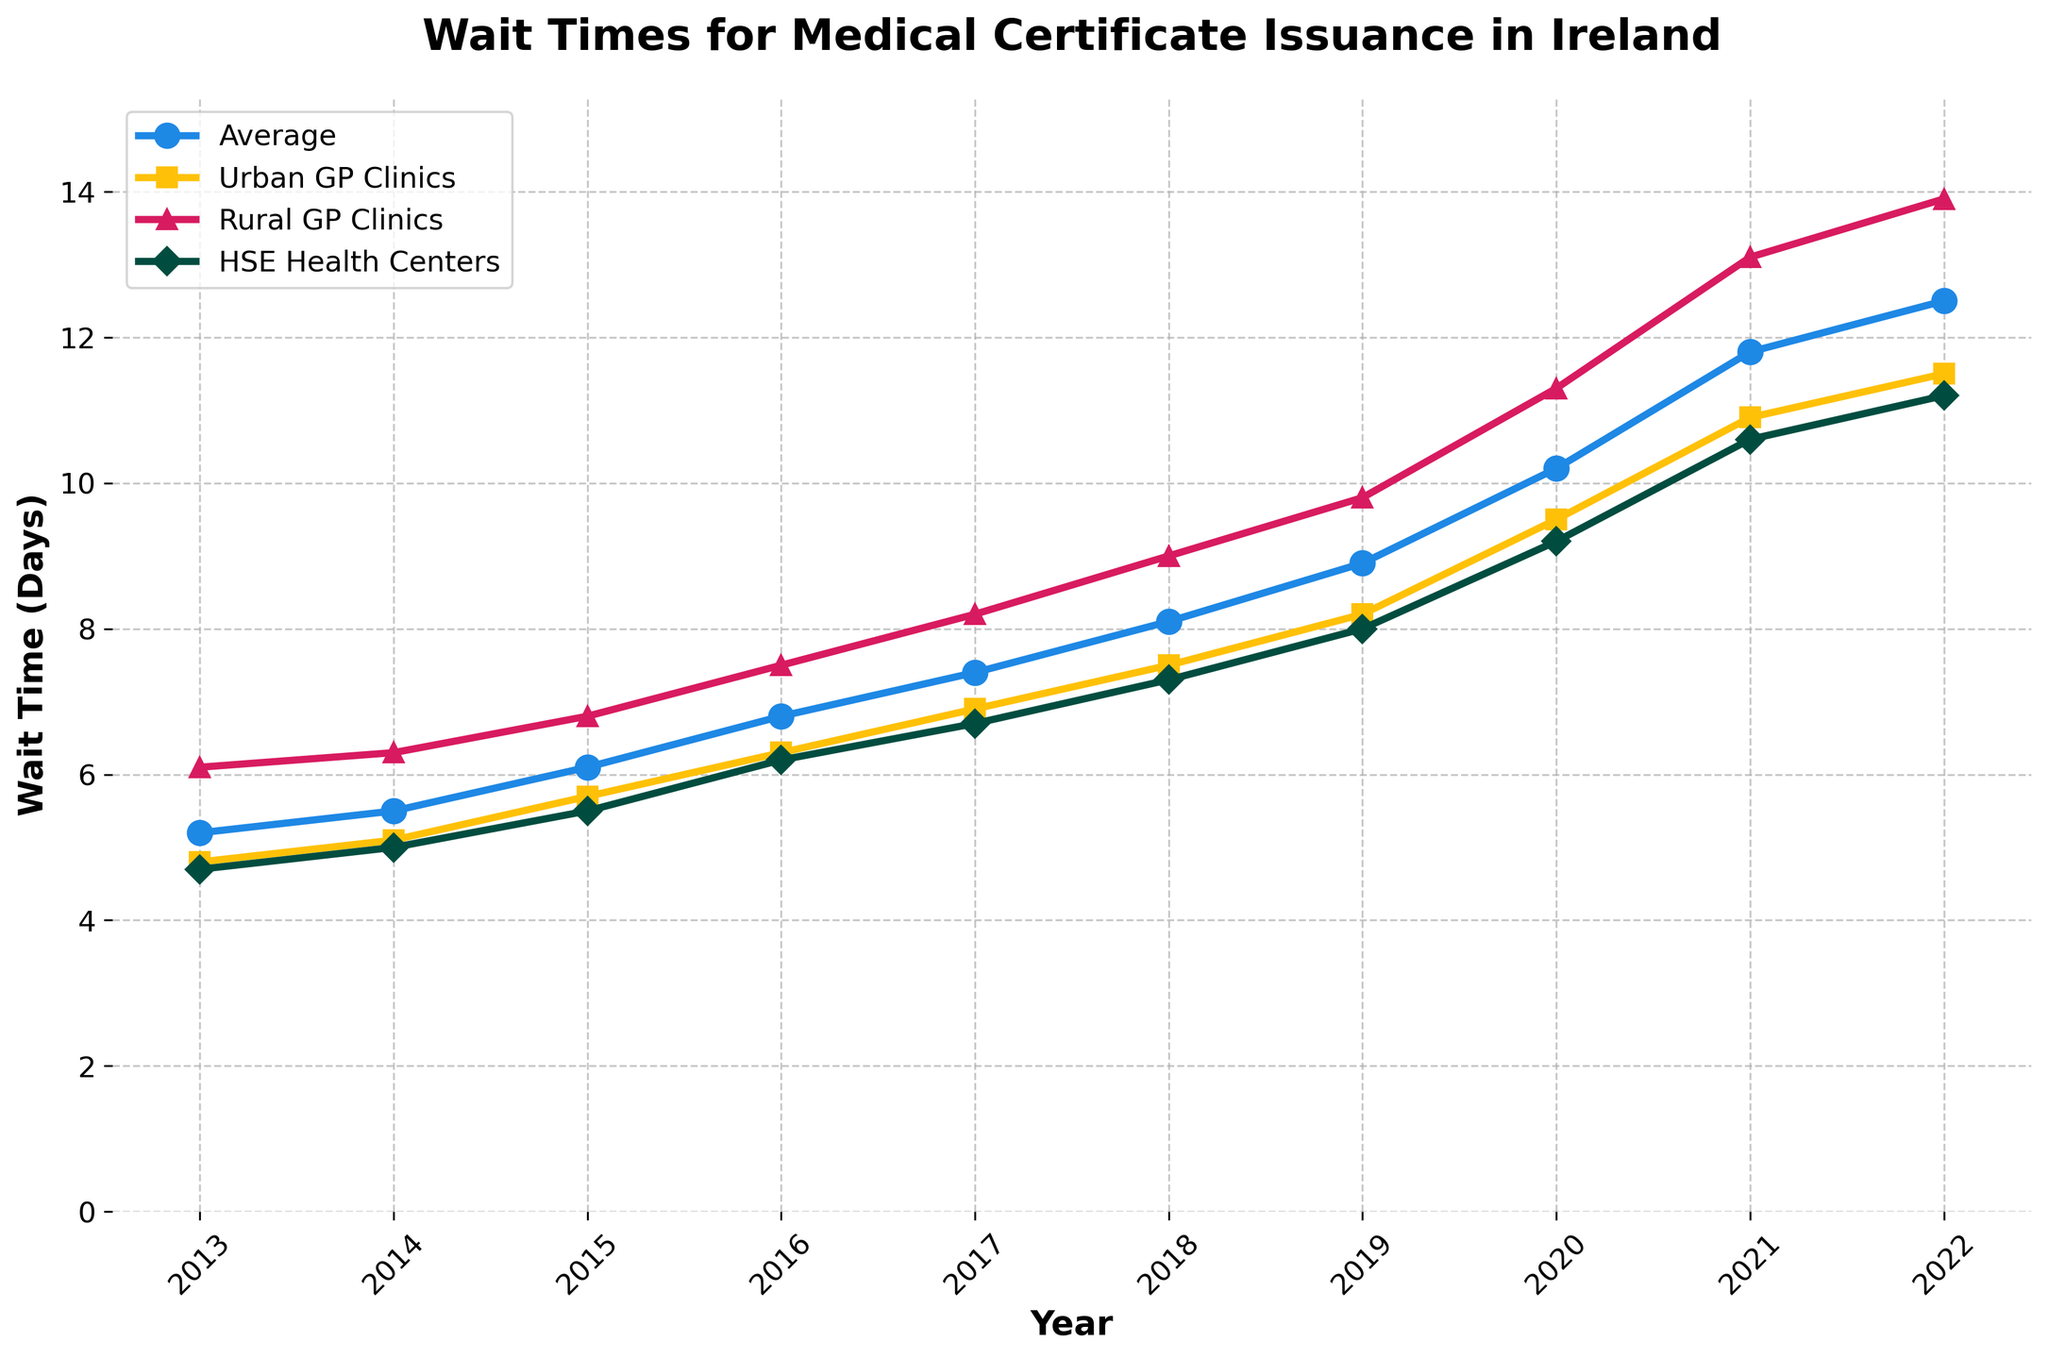What year had the longest average wait time for medical certificates? By looking at the line for 'Average Wait Time (Days)', we see it peaks at 12.5 days in 2022, which is the highest on the chart.
Answer: 2022 Which type of clinic had the highest increase in wait time over the decade? By comparing the start and end values for each clinic type: 
- Urban GP Clinics increased from 4.8 to 11.5 days (6.7 days increase),
- Rural GP Clinics increased from 6.1 to 13.9 days (7.8 days increase),
- HSE Health Centers increased from 4.7 to 11.2 days (6.5 days increase).
Rural GP Clinics had the highest increase.
Answer: Rural GP Clinics How much did the wait time at Urban GP Clinics change between 2015 and 2019? The wait time at Urban GP Clinics was 5.7 days in 2015 and 8.2 days in 2019. The change is 8.2 - 5.7 = 2.5 days.
Answer: 2.5 days Which year did the Rural GP Clinics' wait time exceed 10 days for the first time? By looking at the 'Rural GP Clinics' line, it first exceeds 10 days in 2020.
Answer: 2020 What is the difference in the wait time between Urban GP Clinics and Rural GP Clinics in 2018? In 2018, the wait time for Urban GP Clinics is 7.5 days and for Rural GP Clinics is 9.0 days. The difference is 9.0 - 7.5 = 1.5 days.
Answer: 1.5 days Which type of clinic had the shortest wait time in 2017? By looking at the data points for 2017, 'HSE Health Centers' had the shortest wait time at 6.7 days compared to others.
Answer: HSE Health Centers What is the average wait time for HSE Health Centers over the decade? Summing the wait times for HSE Health Centers from 2013 to 2022 and dividing by the number of years:
(4.7 + 5.0 + 5.5 + 6.2 + 6.7 + 7.3 + 8.0 + 9.2 + 10.6 + 11.2) / 10 = 74.4 / 10 = 7.44 days.
Answer: 7.44 days Between which consecutive years did the average wait time for medical certificate issuance increase the most? Calculating the yearly increases for ‘Average Wait Time (Days)’:
2014-2013: 5.5 - 5.2 = 0.3
2015-2014: 6.1 - 5.5 = 0.6
2016-2015: 6.8 - 6.1 = 0.7
2017-2016: 7.4 - 6.8 = 0.6
2018-2017: 8.1 - 7.4 = 0.7
2019-2018: 8.9 - 8.1 = 0.8
2020-2019: 10.2 - 8.9 = 1.3
2021-2020: 11.8 - 10.2 = 1.6
2022-2021: 12.5 - 11.8 = 0.7
The maximum increase happened between 2020 and 2021.
Answer: 2020-2021 Which clinic type had consistent exponential-like growth over the decade? By observing the trajectory of the lines, 'Rural GP Clinics' shows a consistent and steep increase resembling exponential growth.
Answer: Rural GP Clinics 